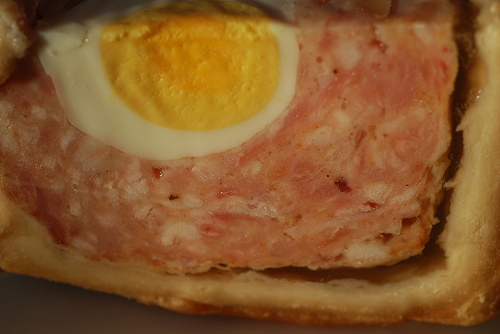<image>
Can you confirm if the egg is in the meat? Yes. The egg is contained within or inside the meat, showing a containment relationship. 